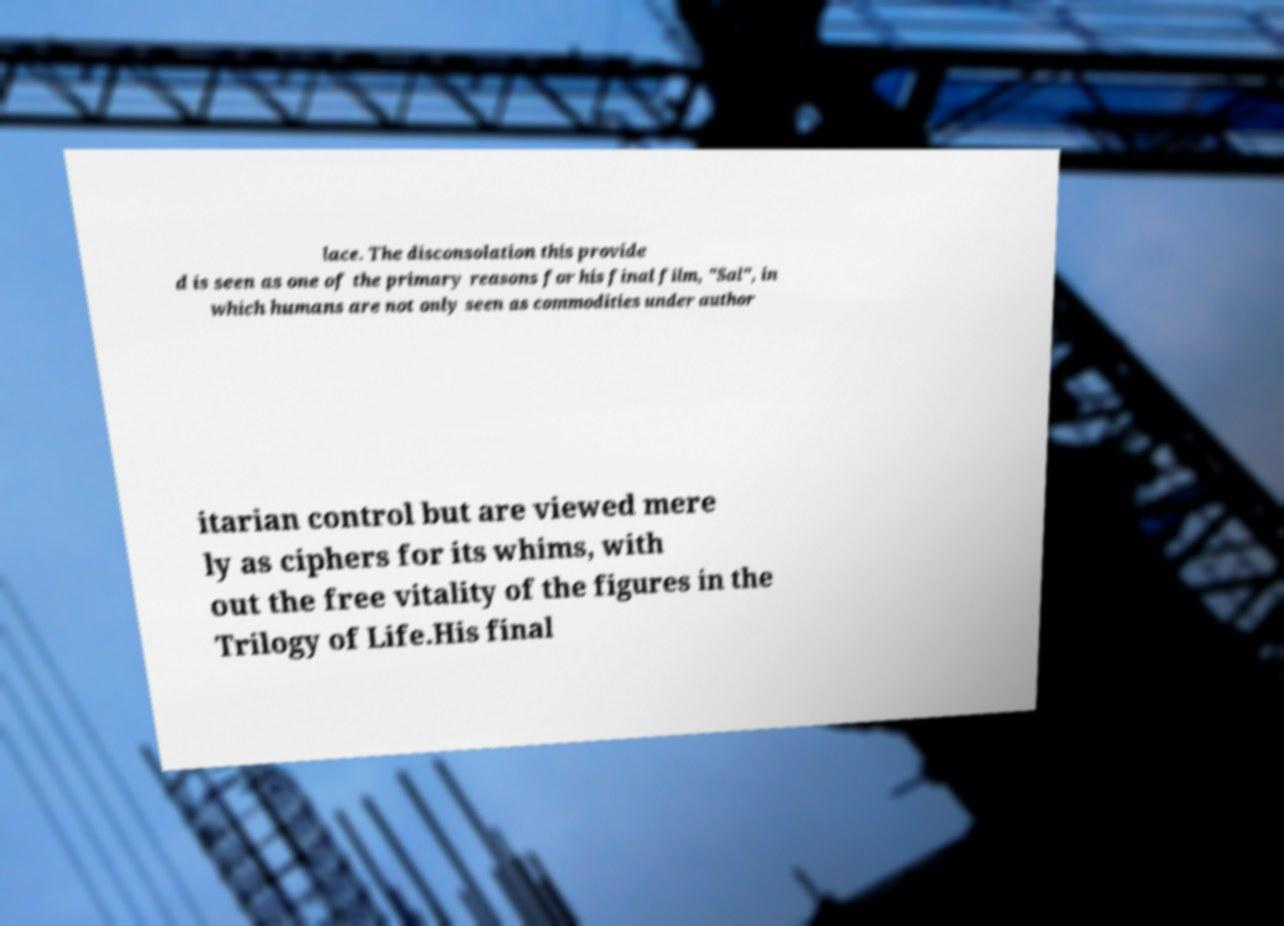What messages or text are displayed in this image? I need them in a readable, typed format. lace. The disconsolation this provide d is seen as one of the primary reasons for his final film, "Sal", in which humans are not only seen as commodities under author itarian control but are viewed mere ly as ciphers for its whims, with out the free vitality of the figures in the Trilogy of Life.His final 